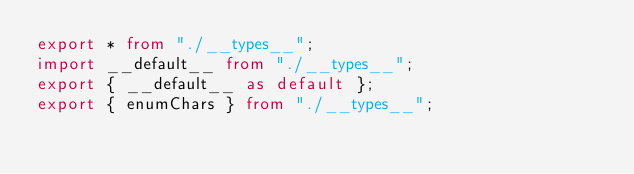<code> <loc_0><loc_0><loc_500><loc_500><_TypeScript_>export * from "./__types__";
import __default__ from "./__types__";
export { __default__ as default };
export { enumChars } from "./__types__";
</code> 